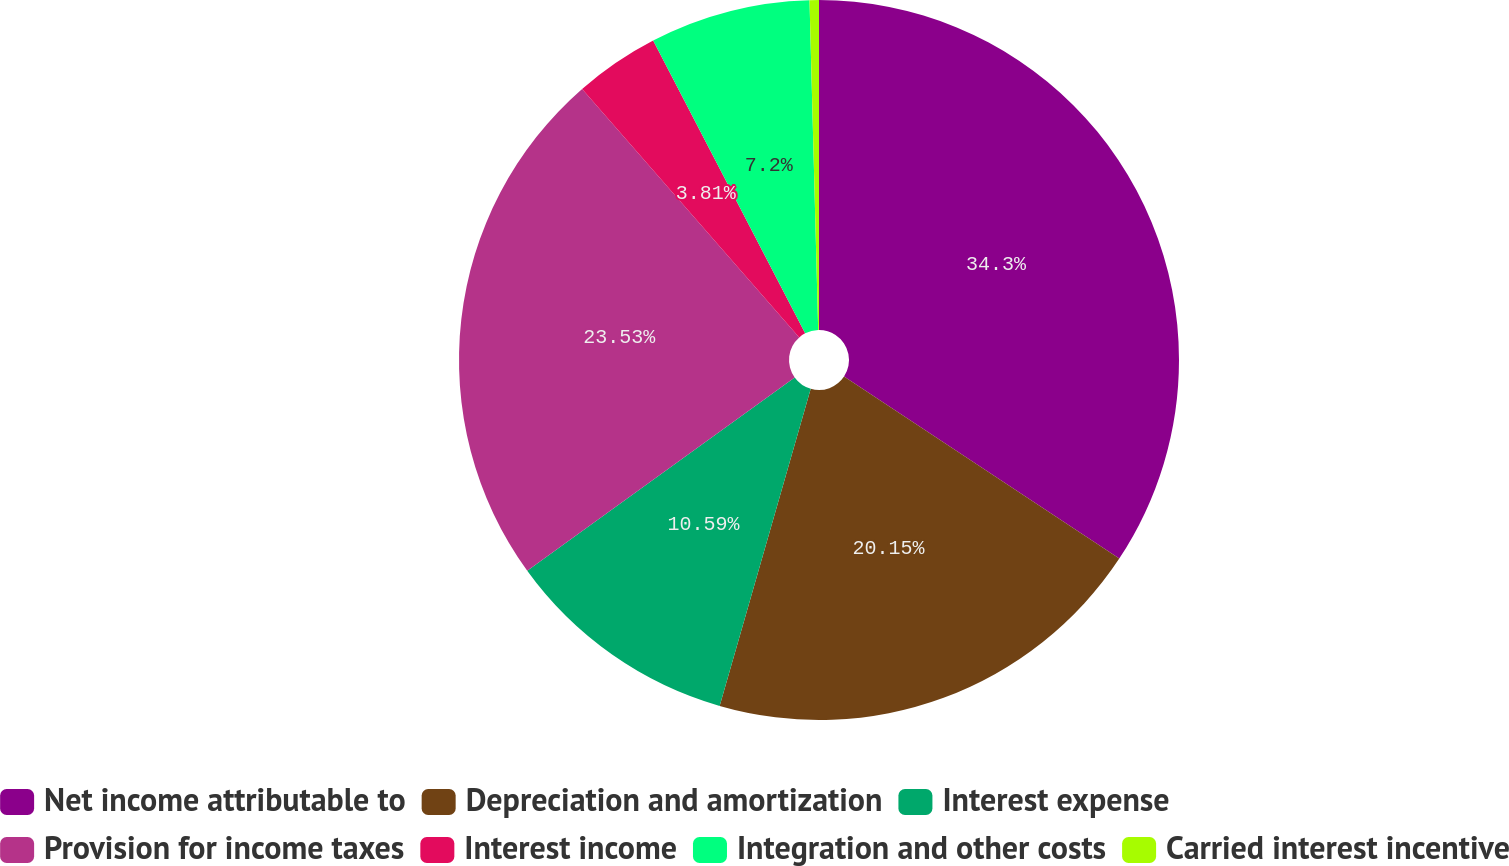Convert chart to OTSL. <chart><loc_0><loc_0><loc_500><loc_500><pie_chart><fcel>Net income attributable to<fcel>Depreciation and amortization<fcel>Interest expense<fcel>Provision for income taxes<fcel>Interest income<fcel>Integration and other costs<fcel>Carried interest incentive<nl><fcel>34.3%<fcel>20.15%<fcel>10.59%<fcel>23.53%<fcel>3.81%<fcel>7.2%<fcel>0.42%<nl></chart> 